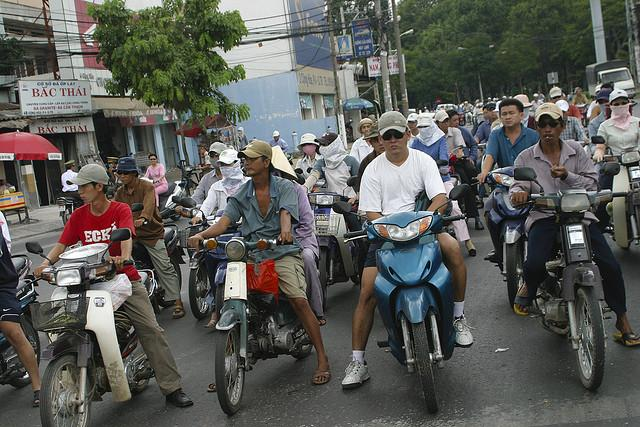What type of area is shown? Please explain your reasoning. urban. This is a more crowded area. 